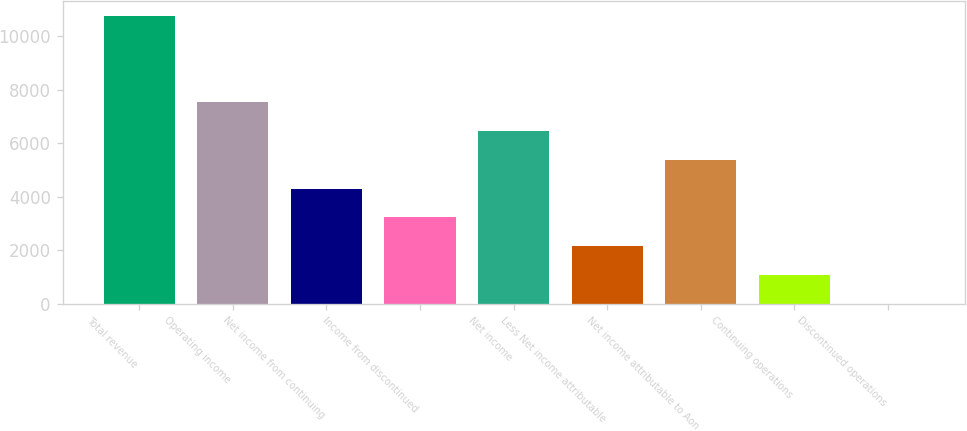<chart> <loc_0><loc_0><loc_500><loc_500><bar_chart><fcel>Total revenue<fcel>Operating income<fcel>Net income from continuing<fcel>Income from discontinued<fcel>Net income<fcel>Less Net income attributable<fcel>Net income attributable to Aon<fcel>Continuing operations<fcel>Discontinued operations<nl><fcel>10770<fcel>7539.09<fcel>4308.18<fcel>3231.21<fcel>6462.12<fcel>2154.24<fcel>5385.15<fcel>1077.27<fcel>0.3<nl></chart> 